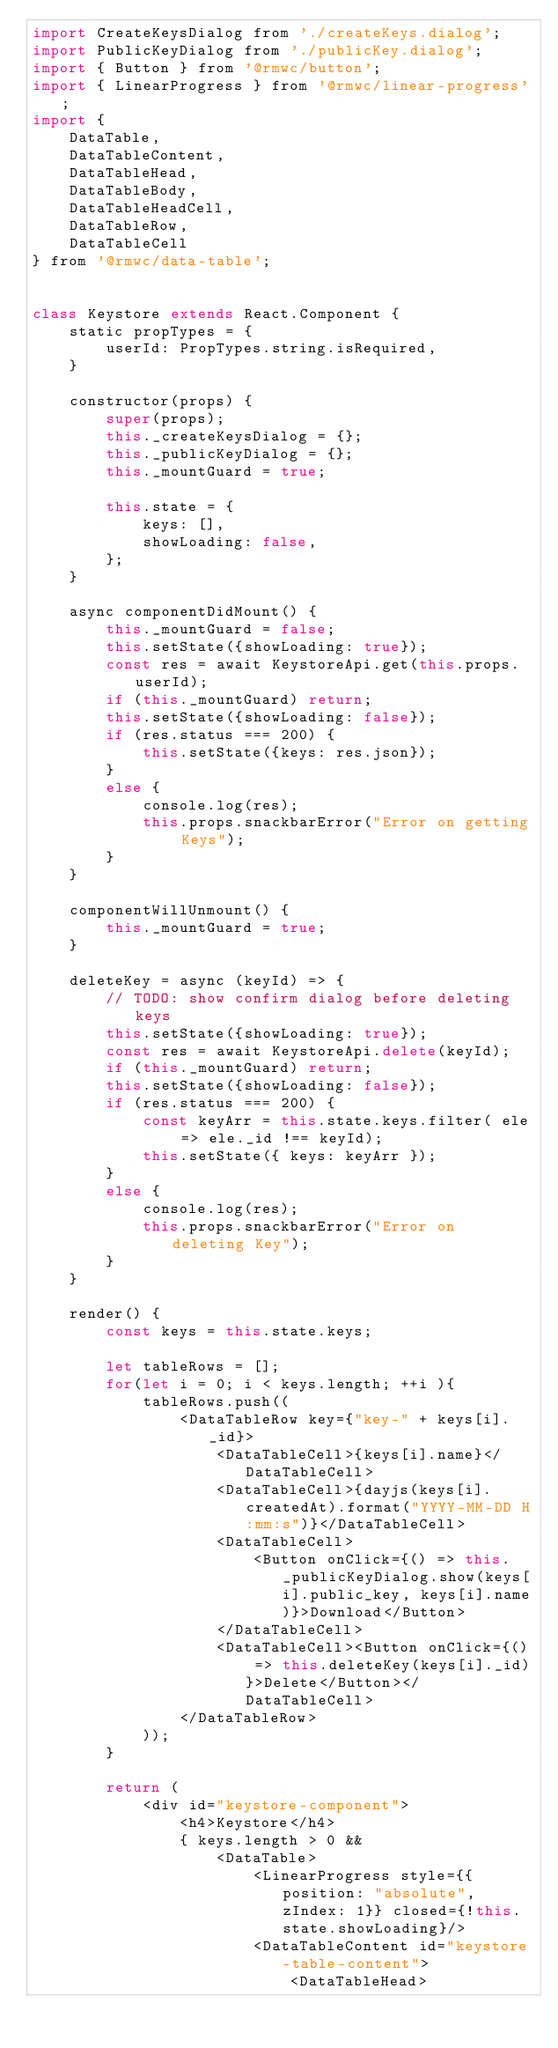<code> <loc_0><loc_0><loc_500><loc_500><_JavaScript_>import CreateKeysDialog from './createKeys.dialog';
import PublicKeyDialog from './publicKey.dialog';
import { Button } from '@rmwc/button';
import { LinearProgress } from '@rmwc/linear-progress';
import {
    DataTable,
    DataTableContent,
    DataTableHead,
    DataTableBody,
    DataTableHeadCell,
    DataTableRow,
    DataTableCell
} from '@rmwc/data-table';


class Keystore extends React.Component {
    static propTypes = {
        userId: PropTypes.string.isRequired,
    }

    constructor(props) {
        super(props);
        this._createKeysDialog = {};
        this._publicKeyDialog = {};
        this._mountGuard = true;

        this.state = {
            keys: [],
            showLoading: false,
        };
    }

    async componentDidMount() {
        this._mountGuard = false;
        this.setState({showLoading: true});
        const res = await KeystoreApi.get(this.props.userId);
        if (this._mountGuard) return;
        this.setState({showLoading: false});
        if (res.status === 200) {
            this.setState({keys: res.json});
        } 
        else {
            console.log(res);
            this.props.snackbarError("Error on getting Keys");
        }
    }

    componentWillUnmount() { 
        this._mountGuard = true; 
    }

    deleteKey = async (keyId) => {
        // TODO: show confirm dialog before deleting keys
        this.setState({showLoading: true});
        const res = await KeystoreApi.delete(keyId);
        if (this._mountGuard) return;
        this.setState({showLoading: false});
        if (res.status === 200) {
            const keyArr = this.state.keys.filter( ele => ele._id !== keyId);
            this.setState({ keys: keyArr });
        }
        else {
            console.log(res);
            this.props.snackbarError("Error on deleting Key");
        }
    }

    render() {
        const keys = this.state.keys;

        let tableRows = [];
        for(let i = 0; i < keys.length; ++i ){
            tableRows.push((
                <DataTableRow key={"key-" + keys[i]._id}>
                    <DataTableCell>{keys[i].name}</DataTableCell>
                    <DataTableCell>{dayjs(keys[i].createdAt).format("YYYY-MM-DD H:mm:s")}</DataTableCell>
                    <DataTableCell>
                        <Button onClick={() => this._publicKeyDialog.show(keys[i].public_key, keys[i].name)}>Download</Button>
                    </DataTableCell>
                    <DataTableCell><Button onClick={() => this.deleteKey(keys[i]._id)}>Delete</Button></DataTableCell>
                </DataTableRow>
            ));
        }

        return (
            <div id="keystore-component">
                <h4>Keystore</h4>
                { keys.length > 0 &&
                    <DataTable>
                        <LinearProgress style={{position: "absolute", zIndex: 1}} closed={!this.state.showLoading}/>
                        <DataTableContent id="keystore-table-content">
                            <DataTableHead></code> 